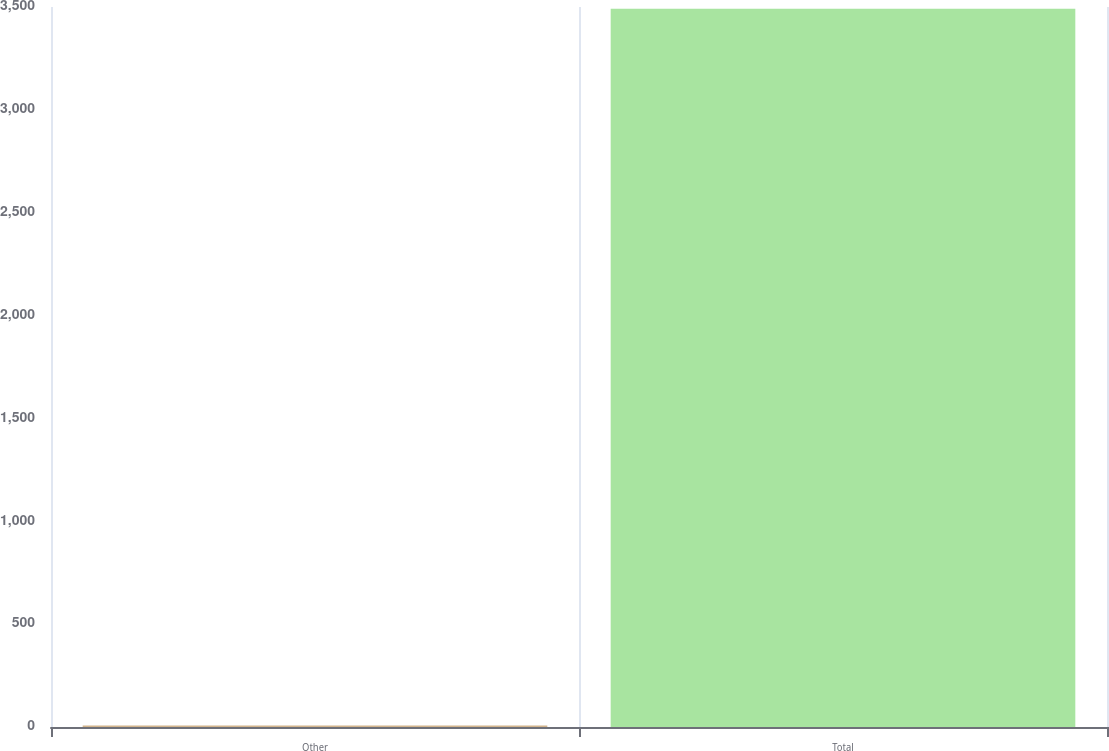Convert chart. <chart><loc_0><loc_0><loc_500><loc_500><bar_chart><fcel>Other<fcel>Total<nl><fcel>7<fcel>3492<nl></chart> 